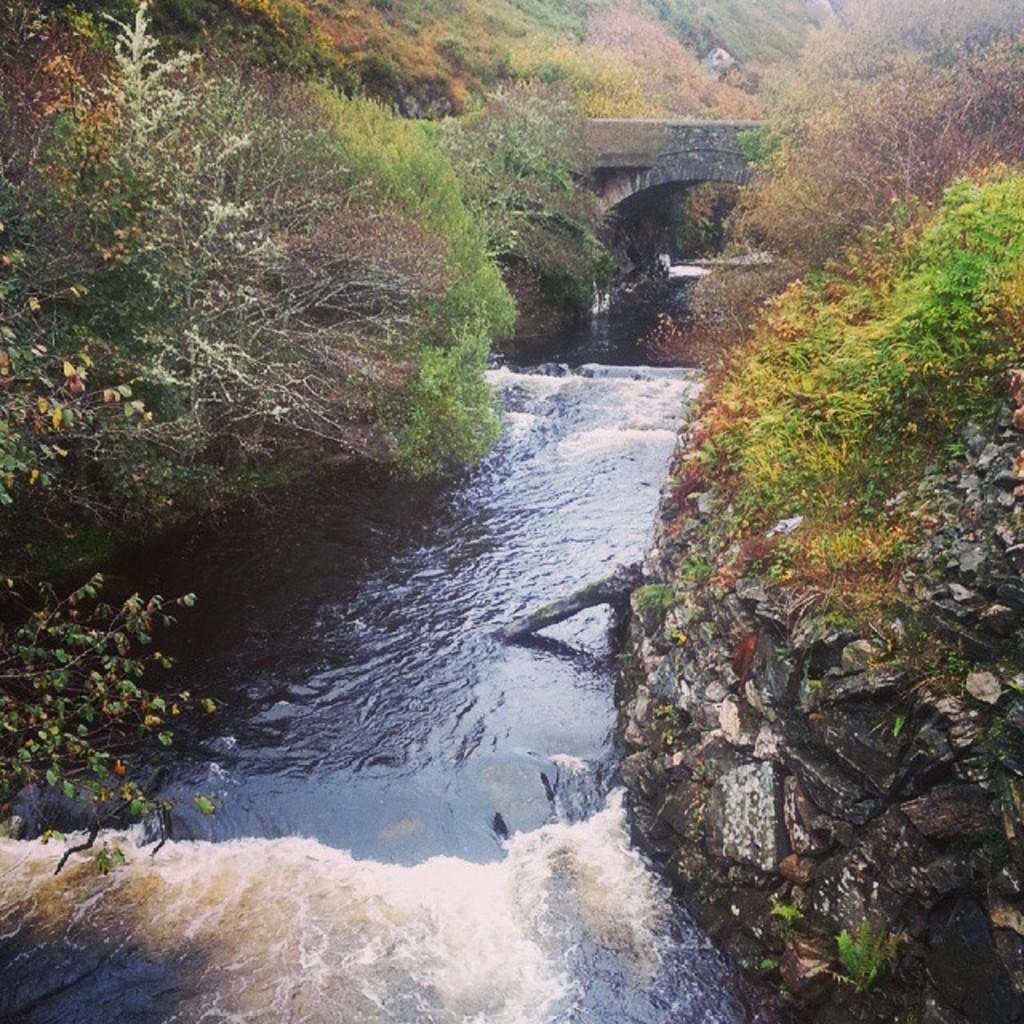Could you give a brief overview of what you see in this image? In this image I can see the water. To the side of the water I can see many trees and the rock. I can also see the bridge in the back. 